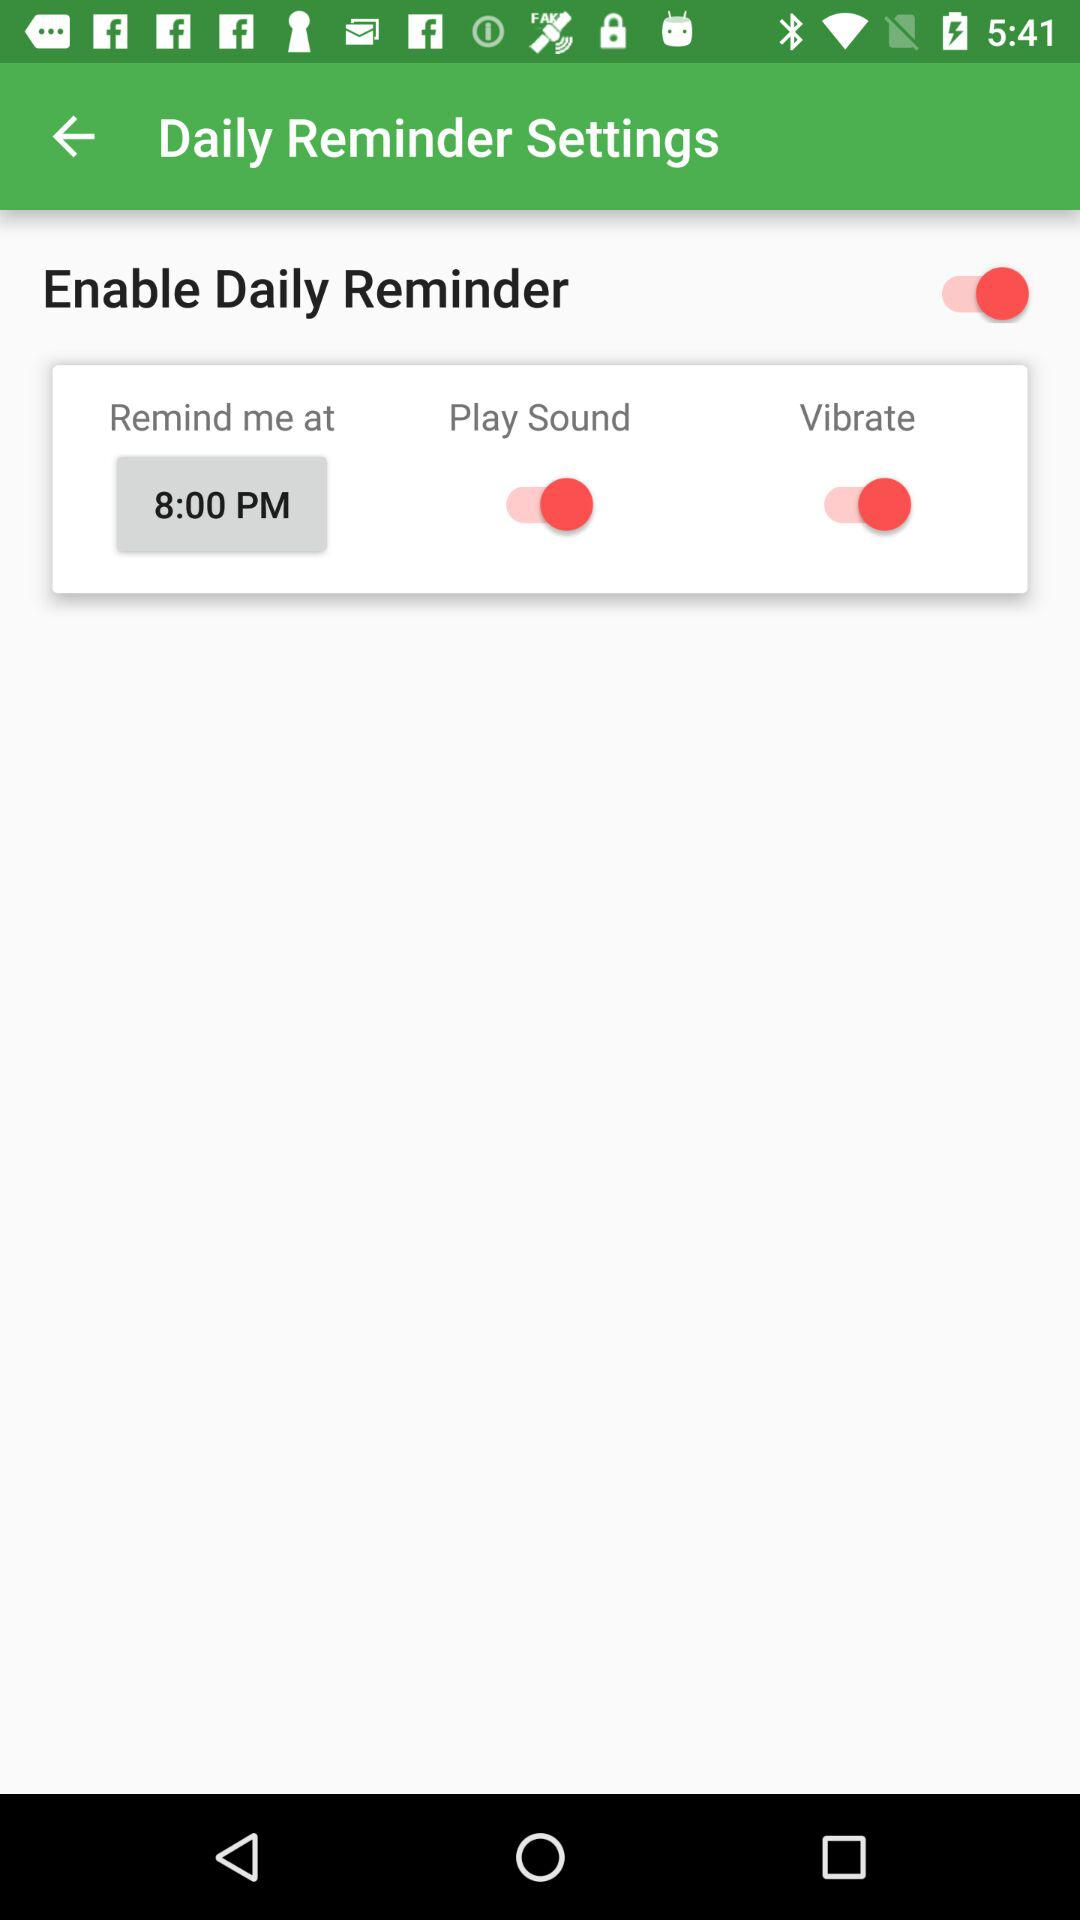What is the time set to remind me? The time duration is 8:00 PM. 